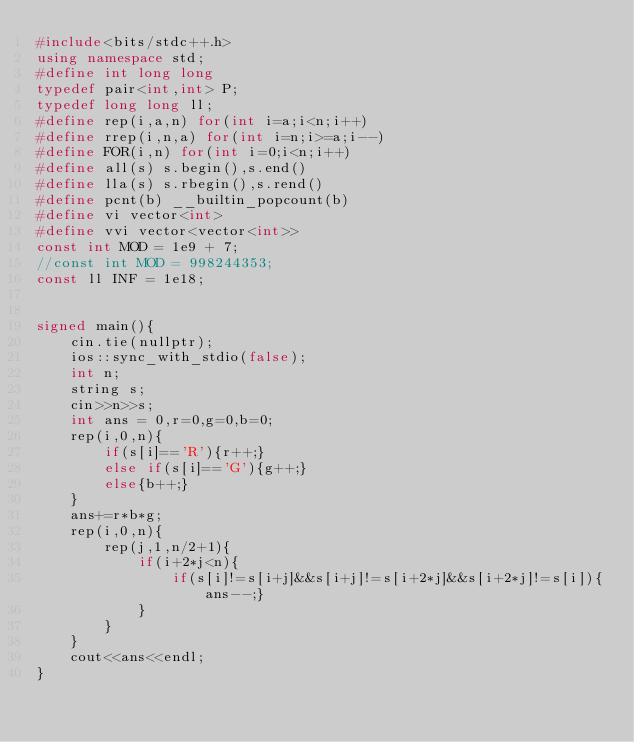<code> <loc_0><loc_0><loc_500><loc_500><_C++_>#include<bits/stdc++.h>
using namespace std;
#define int long long
typedef pair<int,int> P;
typedef long long ll;
#define rep(i,a,n) for(int i=a;i<n;i++)
#define rrep(i,n,a) for(int i=n;i>=a;i--)
#define FOR(i,n) for(int i=0;i<n;i++)
#define all(s) s.begin(),s.end()
#define lla(s) s.rbegin(),s.rend()
#define pcnt(b) __builtin_popcount(b)
#define vi vector<int>
#define vvi vector<vector<int>>
const int MOD = 1e9 + 7;
//const int MOD = 998244353;
const ll INF = 1e18;


signed main(){
    cin.tie(nullptr);
    ios::sync_with_stdio(false);
    int n;
    string s;
    cin>>n>>s;
    int ans = 0,r=0,g=0,b=0;
    rep(i,0,n){
        if(s[i]=='R'){r++;}
        else if(s[i]=='G'){g++;}
        else{b++;}
    }
    ans+=r*b*g;
    rep(i,0,n){
        rep(j,1,n/2+1){
            if(i+2*j<n){
                if(s[i]!=s[i+j]&&s[i+j]!=s[i+2*j]&&s[i+2*j]!=s[i]){ans--;}
            }
        }
    }
    cout<<ans<<endl;
}</code> 